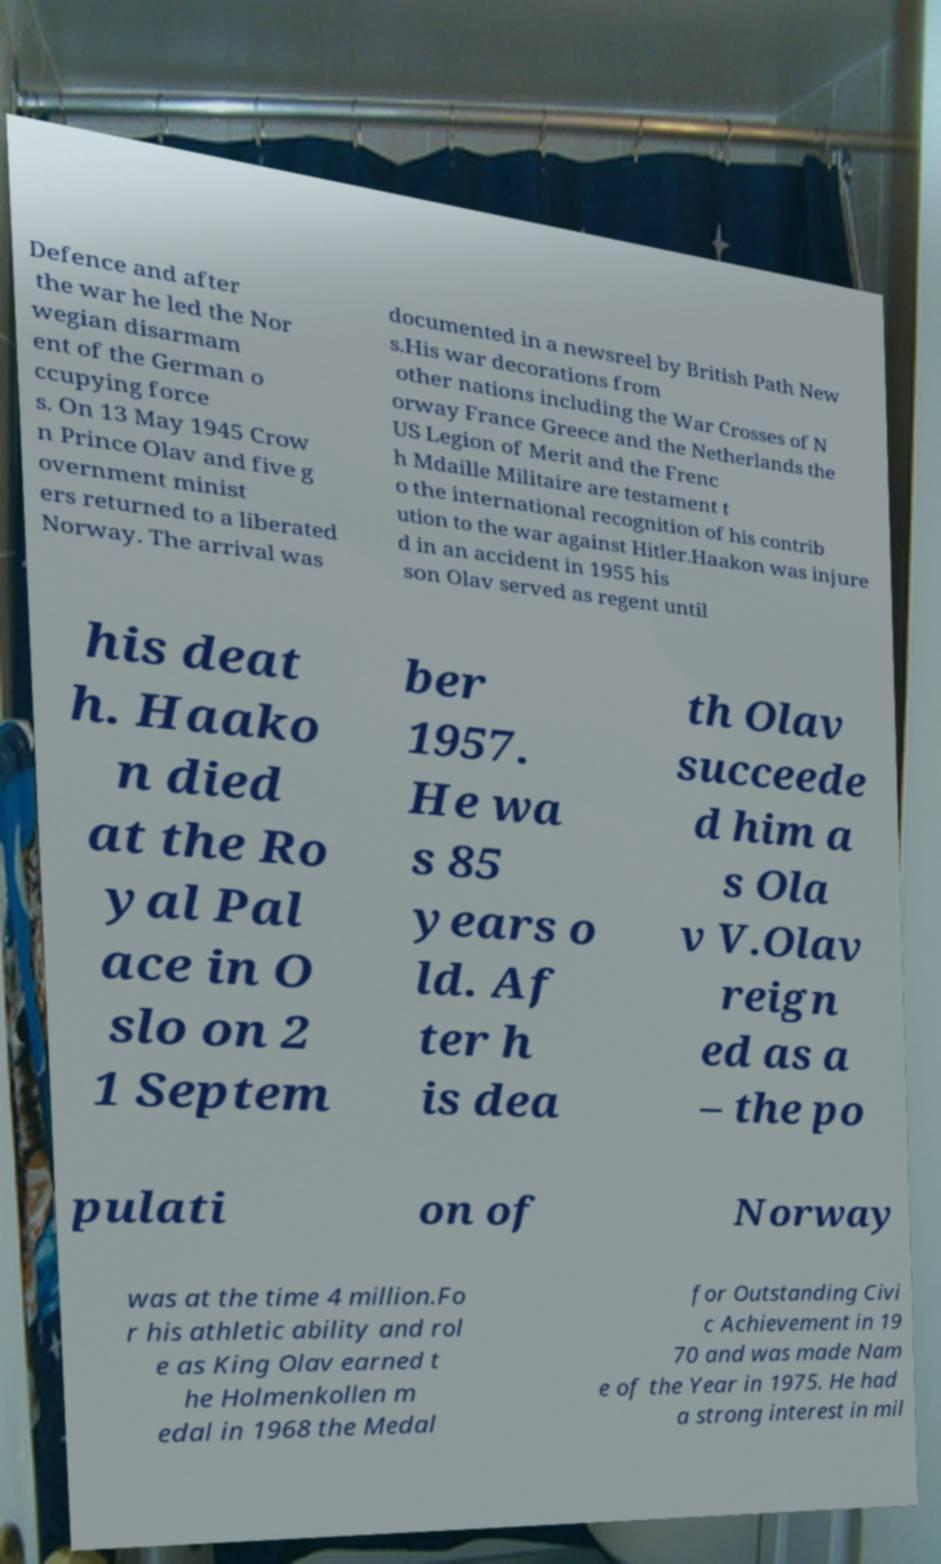Please read and relay the text visible in this image. What does it say? Defence and after the war he led the Nor wegian disarmam ent of the German o ccupying force s. On 13 May 1945 Crow n Prince Olav and five g overnment minist ers returned to a liberated Norway. The arrival was documented in a newsreel by British Path New s.His war decorations from other nations including the War Crosses of N orway France Greece and the Netherlands the US Legion of Merit and the Frenc h Mdaille Militaire are testament t o the international recognition of his contrib ution to the war against Hitler.Haakon was injure d in an accident in 1955 his son Olav served as regent until his deat h. Haako n died at the Ro yal Pal ace in O slo on 2 1 Septem ber 1957. He wa s 85 years o ld. Af ter h is dea th Olav succeede d him a s Ola v V.Olav reign ed as a – the po pulati on of Norway was at the time 4 million.Fo r his athletic ability and rol e as King Olav earned t he Holmenkollen m edal in 1968 the Medal for Outstanding Civi c Achievement in 19 70 and was made Nam e of the Year in 1975. He had a strong interest in mil 